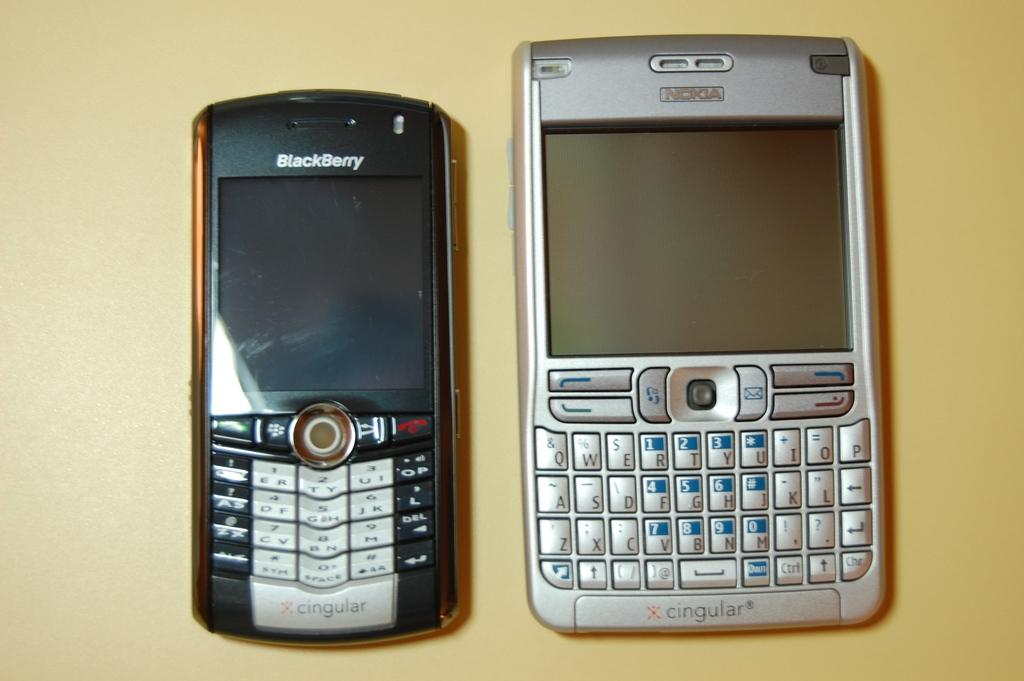<image>
Describe the image concisely. A blackberry phone is side by side with a Nokia phone. 